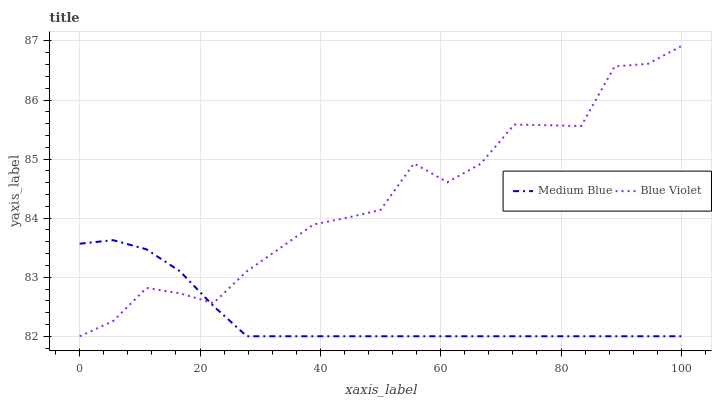Does Medium Blue have the minimum area under the curve?
Answer yes or no. Yes. Does Blue Violet have the maximum area under the curve?
Answer yes or no. Yes. Does Blue Violet have the minimum area under the curve?
Answer yes or no. No. Is Medium Blue the smoothest?
Answer yes or no. Yes. Is Blue Violet the roughest?
Answer yes or no. Yes. Is Blue Violet the smoothest?
Answer yes or no. No. Does Medium Blue have the lowest value?
Answer yes or no. Yes. Does Blue Violet have the highest value?
Answer yes or no. Yes. Does Blue Violet intersect Medium Blue?
Answer yes or no. Yes. Is Blue Violet less than Medium Blue?
Answer yes or no. No. Is Blue Violet greater than Medium Blue?
Answer yes or no. No. 